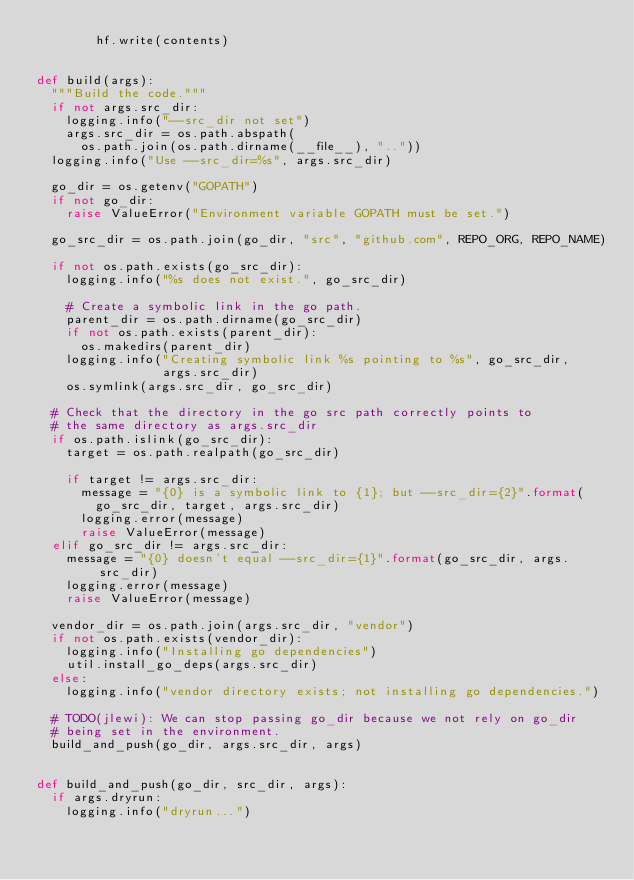Convert code to text. <code><loc_0><loc_0><loc_500><loc_500><_Python_>        hf.write(contents)


def build(args):
  """Build the code."""
  if not args.src_dir:
    logging.info("--src_dir not set")
    args.src_dir = os.path.abspath(
      os.path.join(os.path.dirname(__file__), ".."))
  logging.info("Use --src_dir=%s", args.src_dir)

  go_dir = os.getenv("GOPATH")
  if not go_dir:
    raise ValueError("Environment variable GOPATH must be set.")

  go_src_dir = os.path.join(go_dir, "src", "github.com", REPO_ORG, REPO_NAME)

  if not os.path.exists(go_src_dir):
    logging.info("%s does not exist.", go_src_dir)

    # Create a symbolic link in the go path.
    parent_dir = os.path.dirname(go_src_dir)
    if not os.path.exists(parent_dir):
      os.makedirs(parent_dir)
    logging.info("Creating symbolic link %s pointing to %s", go_src_dir,
                 args.src_dir)
    os.symlink(args.src_dir, go_src_dir)

  # Check that the directory in the go src path correctly points to
  # the same directory as args.src_dir
  if os.path.islink(go_src_dir):
    target = os.path.realpath(go_src_dir)

    if target != args.src_dir:
      message = "{0} is a symbolic link to {1}; but --src_dir={2}".format(
        go_src_dir, target, args.src_dir)
      logging.error(message)
      raise ValueError(message)
  elif go_src_dir != args.src_dir:
    message = "{0} doesn't equal --src_dir={1}".format(go_src_dir, args.src_dir)
    logging.error(message)
    raise ValueError(message)

  vendor_dir = os.path.join(args.src_dir, "vendor")
  if not os.path.exists(vendor_dir):
    logging.info("Installing go dependencies")
    util.install_go_deps(args.src_dir)
  else:
    logging.info("vendor directory exists; not installing go dependencies.")

  # TODO(jlewi): We can stop passing go_dir because we not rely on go_dir
  # being set in the environment.
  build_and_push(go_dir, args.src_dir, args)


def build_and_push(go_dir, src_dir, args):
  if args.dryrun:
    logging.info("dryrun...")</code> 